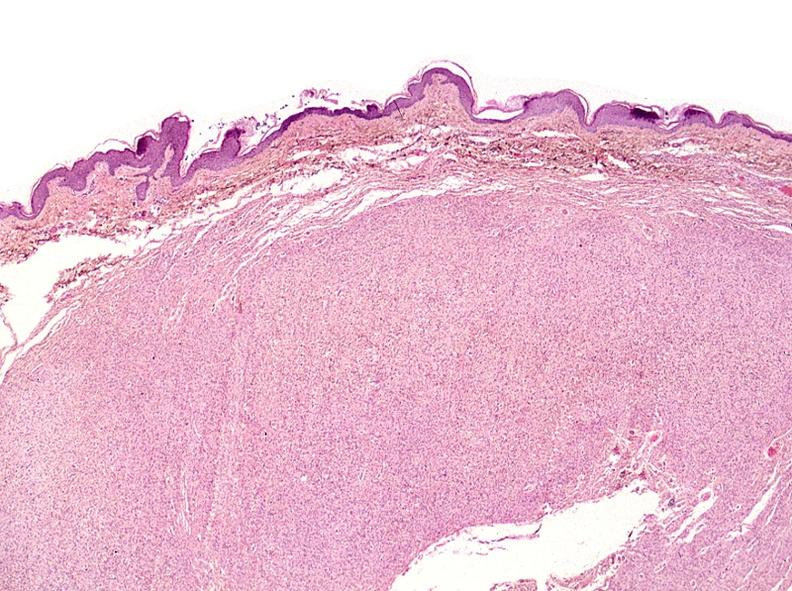what does this image show?
Answer the question using a single word or phrase. Skin 